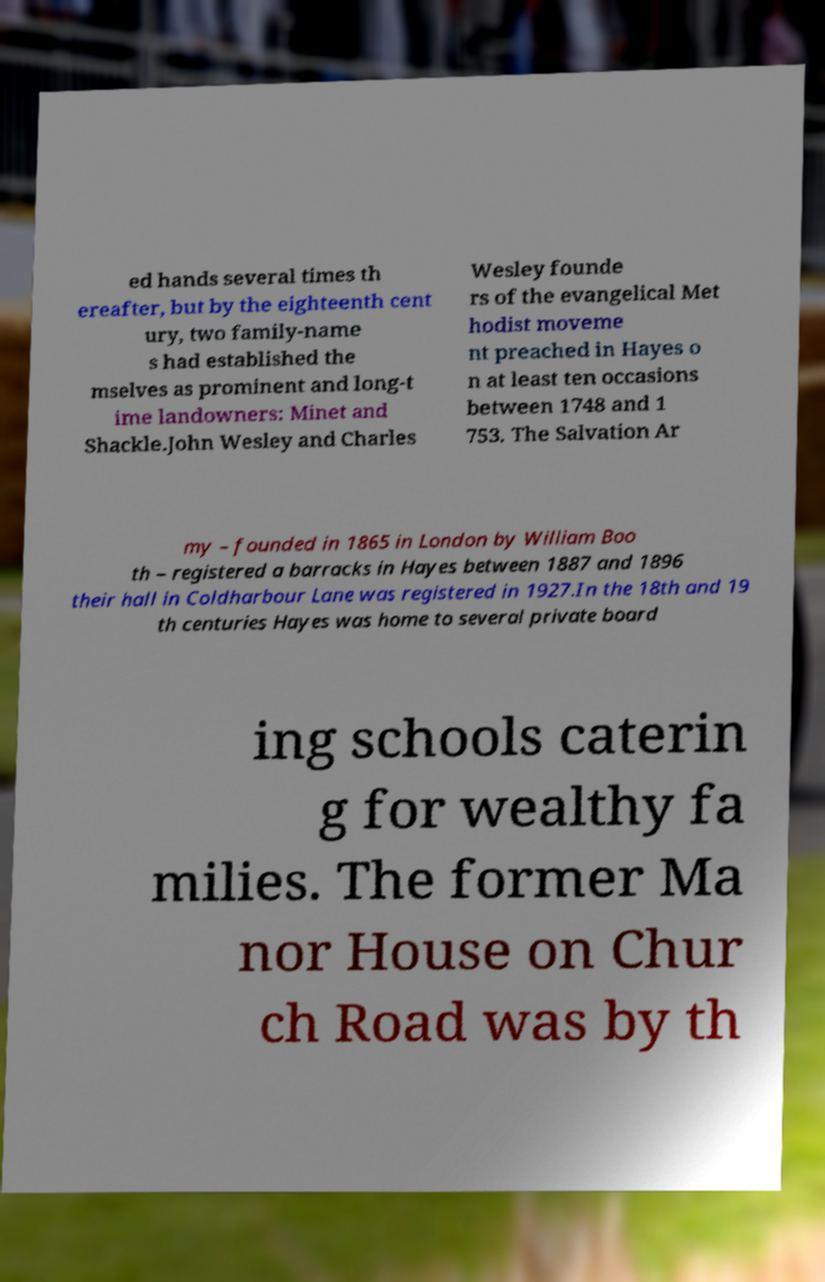There's text embedded in this image that I need extracted. Can you transcribe it verbatim? ed hands several times th ereafter, but by the eighteenth cent ury, two family-name s had established the mselves as prominent and long-t ime landowners: Minet and Shackle.John Wesley and Charles Wesley founde rs of the evangelical Met hodist moveme nt preached in Hayes o n at least ten occasions between 1748 and 1 753. The Salvation Ar my – founded in 1865 in London by William Boo th – registered a barracks in Hayes between 1887 and 1896 their hall in Coldharbour Lane was registered in 1927.In the 18th and 19 th centuries Hayes was home to several private board ing schools caterin g for wealthy fa milies. The former Ma nor House on Chur ch Road was by th 